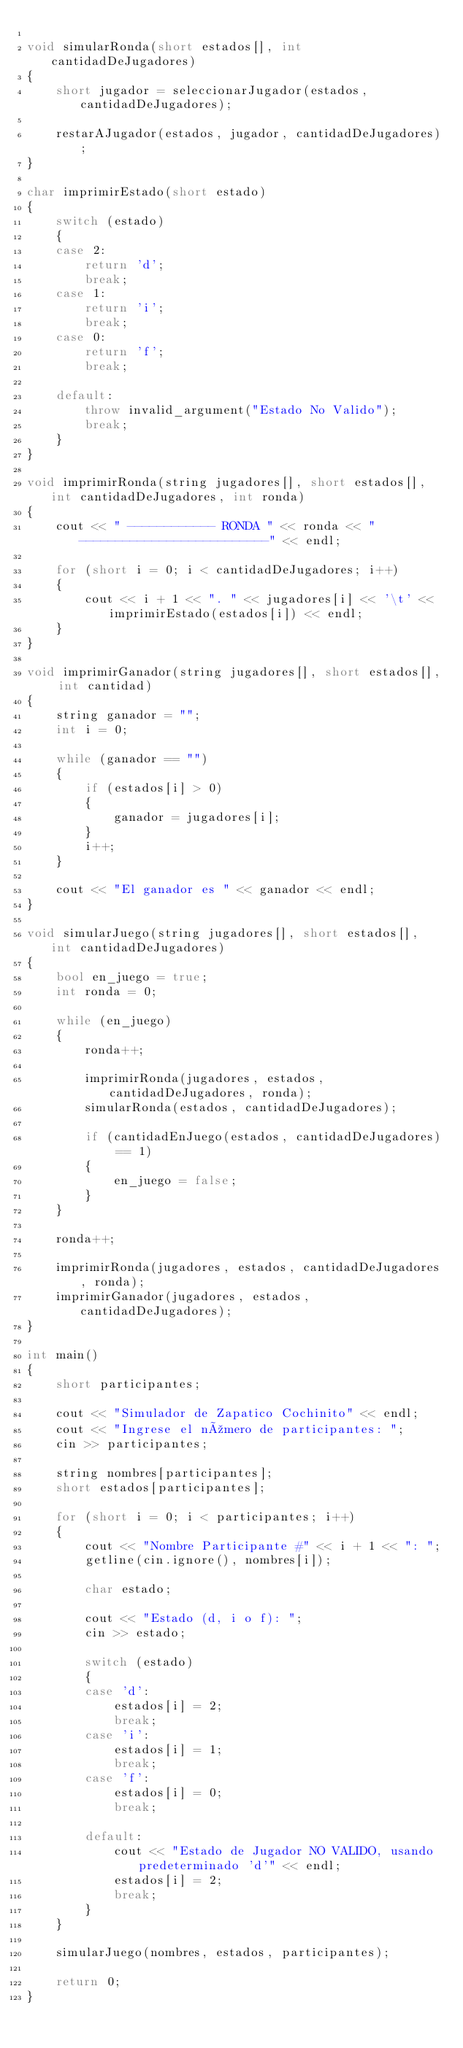<code> <loc_0><loc_0><loc_500><loc_500><_C++_>
void simularRonda(short estados[], int cantidadDeJugadores)
{
	short jugador = seleccionarJugador(estados, cantidadDeJugadores);

	restarAJugador(estados, jugador, cantidadDeJugadores);
}

char imprimirEstado(short estado)
{
	switch (estado)
	{
	case 2:
		return 'd';
		break;
	case 1:
		return 'i';
		break;
	case 0:
		return 'f';
		break;

	default:
		throw invalid_argument("Estado No Valido");
		break;
	}
}

void imprimirRonda(string jugadores[], short estados[], int cantidadDeJugadores, int ronda)
{
	cout << " ------------ RONDA " << ronda << " --------------------------" << endl;

	for (short i = 0; i < cantidadDeJugadores; i++)
	{
		cout << i + 1 << ". " << jugadores[i] << '\t' << imprimirEstado(estados[i]) << endl;
	}
}

void imprimirGanador(string jugadores[], short estados[], int cantidad)
{
	string ganador = "";
	int i = 0;

	while (ganador == "")
	{
		if (estados[i] > 0)
		{
			ganador = jugadores[i];
		}
		i++;
	}

	cout << "El ganador es " << ganador << endl;
}

void simularJuego(string jugadores[], short estados[], int cantidadDeJugadores)
{
	bool en_juego = true;
	int ronda = 0;

	while (en_juego)
	{
		ronda++;

		imprimirRonda(jugadores, estados, cantidadDeJugadores, ronda);
		simularRonda(estados, cantidadDeJugadores);

		if (cantidadEnJuego(estados, cantidadDeJugadores) == 1)
		{
			en_juego = false;
		}
	}

	ronda++;

	imprimirRonda(jugadores, estados, cantidadDeJugadores, ronda);
	imprimirGanador(jugadores, estados, cantidadDeJugadores);
}

int main()
{
	short participantes;

	cout << "Simulador de Zapatico Cochinito" << endl;
	cout << "Ingrese el número de participantes: ";
	cin >> participantes;

	string nombres[participantes];
	short estados[participantes];

	for (short i = 0; i < participantes; i++)
	{
		cout << "Nombre Participante #" << i + 1 << ": ";
		getline(cin.ignore(), nombres[i]);

		char estado;

		cout << "Estado (d, i o f): ";
		cin >> estado;

		switch (estado)
		{
		case 'd':
			estados[i] = 2;
			break;
		case 'i':
			estados[i] = 1;
			break;
		case 'f':
			estados[i] = 0;
			break;

		default:
			cout << "Estado de Jugador NO VALIDO, usando predeterminado 'd'" << endl;
			estados[i] = 2;
			break;
		}
	}

	simularJuego(nombres, estados, participantes);

	return 0;
}</code> 